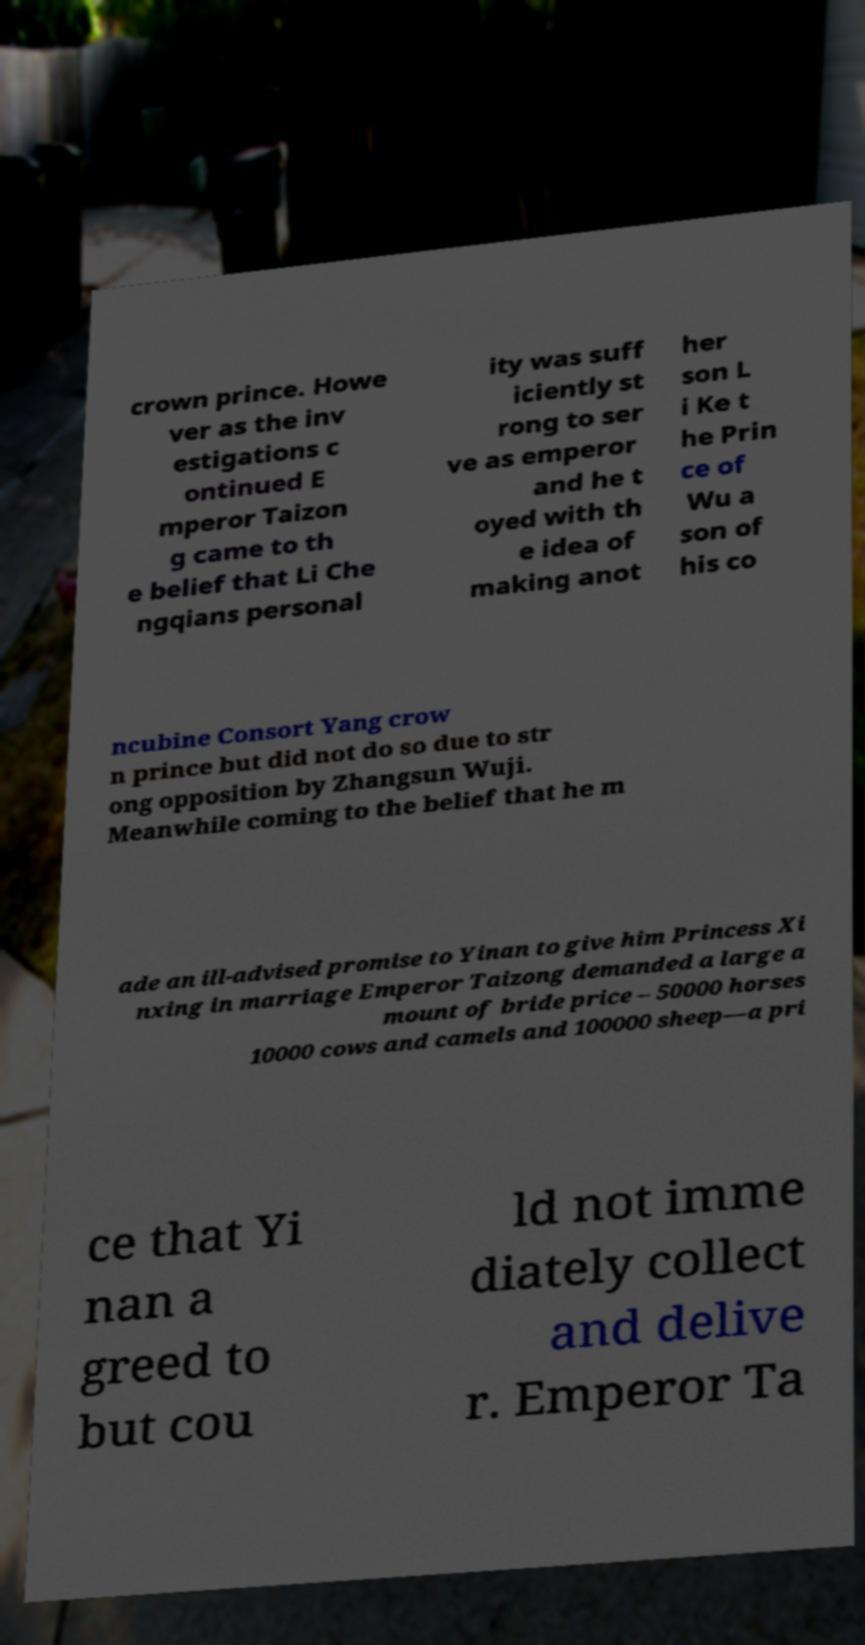What messages or text are displayed in this image? I need them in a readable, typed format. crown prince. Howe ver as the inv estigations c ontinued E mperor Taizon g came to th e belief that Li Che ngqians personal ity was suff iciently st rong to ser ve as emperor and he t oyed with th e idea of making anot her son L i Ke t he Prin ce of Wu a son of his co ncubine Consort Yang crow n prince but did not do so due to str ong opposition by Zhangsun Wuji. Meanwhile coming to the belief that he m ade an ill-advised promise to Yinan to give him Princess Xi nxing in marriage Emperor Taizong demanded a large a mount of bride price – 50000 horses 10000 cows and camels and 100000 sheep—a pri ce that Yi nan a greed to but cou ld not imme diately collect and delive r. Emperor Ta 